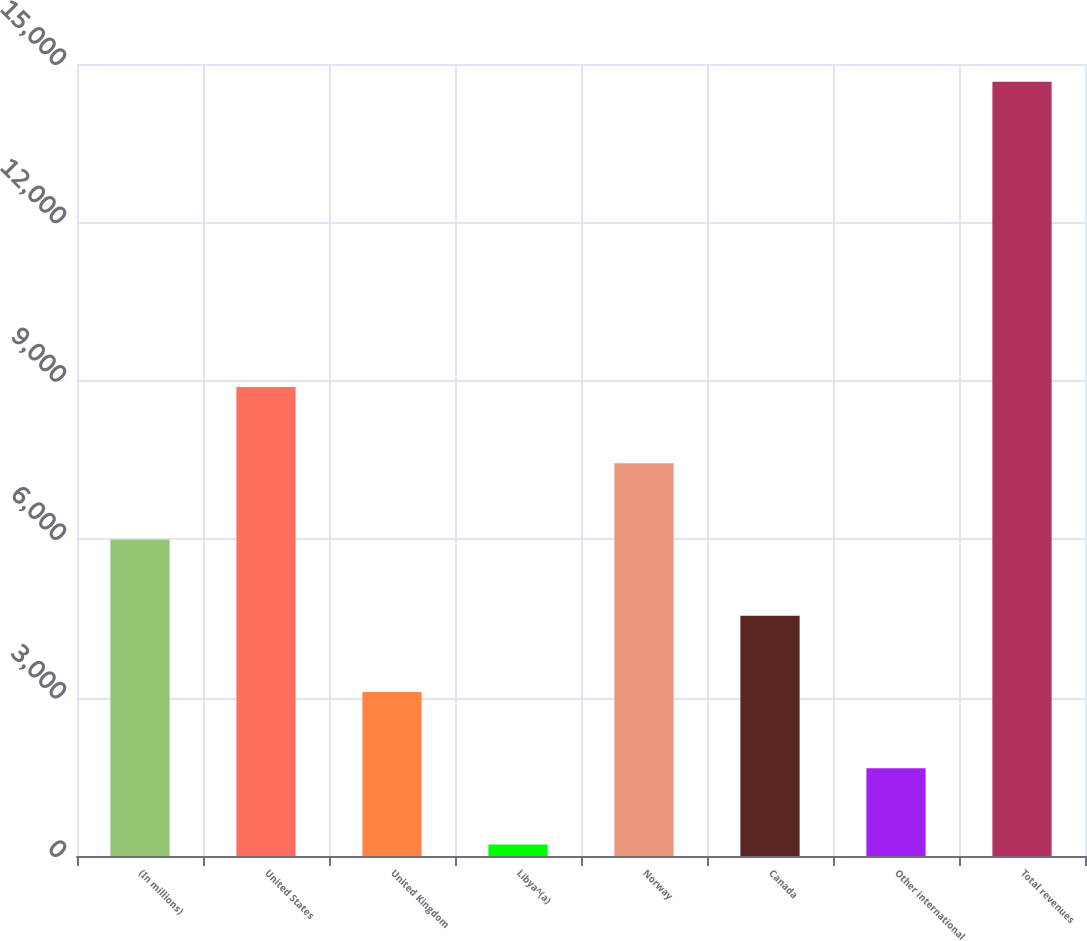<chart> <loc_0><loc_0><loc_500><loc_500><bar_chart><fcel>(In millions)<fcel>United States<fcel>United Kingdom<fcel>Libya^(a)<fcel>Norway<fcel>Canada<fcel>Other international<fcel>Total revenues<nl><fcel>5994.8<fcel>8884.2<fcel>3105.4<fcel>216<fcel>7439.5<fcel>4550.1<fcel>1660.7<fcel>14663<nl></chart> 